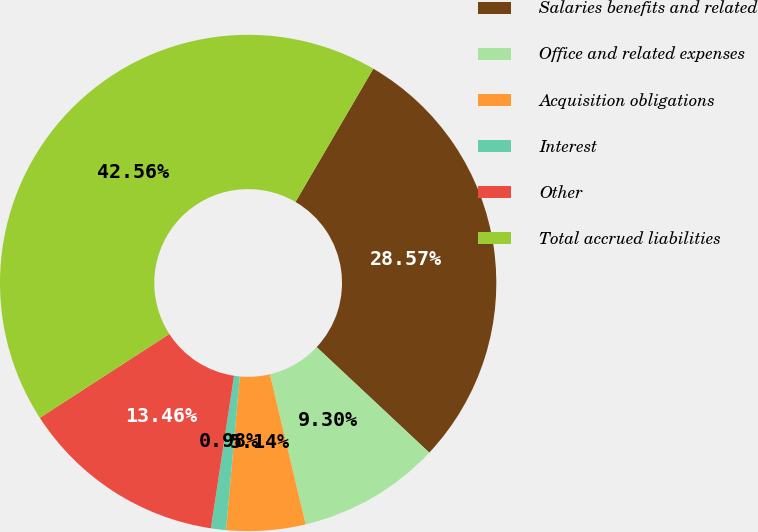Convert chart. <chart><loc_0><loc_0><loc_500><loc_500><pie_chart><fcel>Salaries benefits and related<fcel>Office and related expenses<fcel>Acquisition obligations<fcel>Interest<fcel>Other<fcel>Total accrued liabilities<nl><fcel>28.57%<fcel>9.3%<fcel>5.14%<fcel>0.98%<fcel>13.46%<fcel>42.56%<nl></chart> 